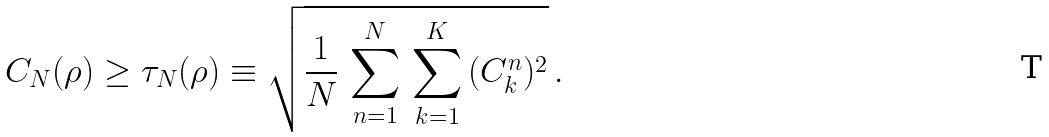Convert formula to latex. <formula><loc_0><loc_0><loc_500><loc_500>C _ { N } ( \rho ) \geq \tau _ { N } ( \rho ) \equiv \sqrt { \frac { 1 } { N } \, \sum _ { n = 1 } ^ { N } \, \sum _ { k = 1 } ^ { K } \, ( C _ { k } ^ { n } ) ^ { 2 } } \, .</formula> 